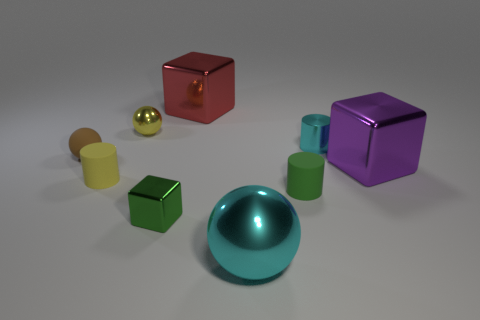Add 1 brown matte spheres. How many objects exist? 10 Subtract all brown balls. How many balls are left? 2 Subtract all gray shiny cubes. Subtract all metallic objects. How many objects are left? 3 Add 6 green matte objects. How many green matte objects are left? 7 Add 4 small green shiny balls. How many small green shiny balls exist? 4 Subtract all yellow cylinders. How many cylinders are left? 2 Subtract 0 purple spheres. How many objects are left? 9 Subtract all balls. How many objects are left? 6 Subtract 1 cylinders. How many cylinders are left? 2 Subtract all cyan blocks. Subtract all green balls. How many blocks are left? 3 